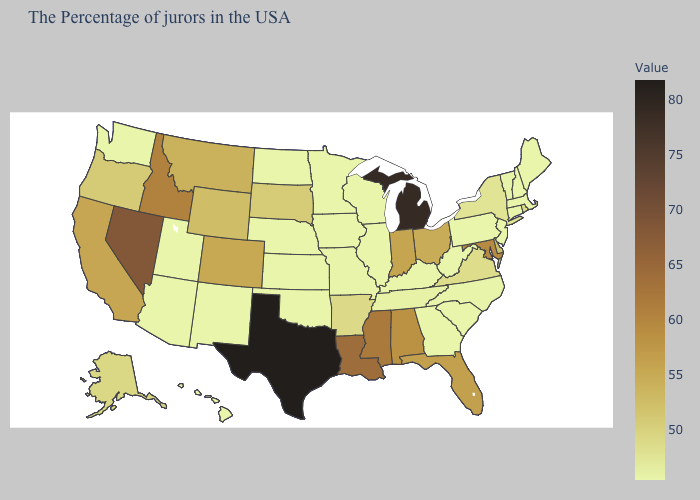Which states have the highest value in the USA?
Concise answer only. Texas. Does Rhode Island have the highest value in the Northeast?
Be succinct. Yes. Does Indiana have a lower value than Nebraska?
Quick response, please. No. Does Alaska have a higher value than Ohio?
Short answer required. No. Is the legend a continuous bar?
Keep it brief. Yes. 